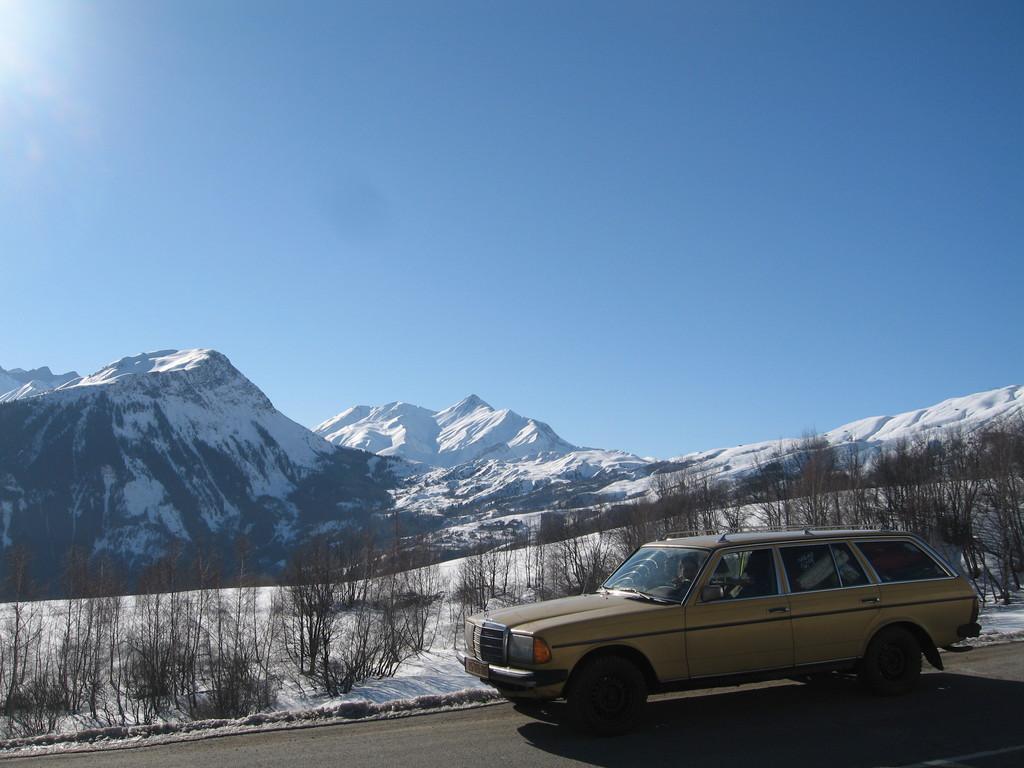Describe this image in one or two sentences. In this picture we can see a car on the road. There are few plants from left to right. We can see few mountains covered with snow in the background. Sky is blue in color. 